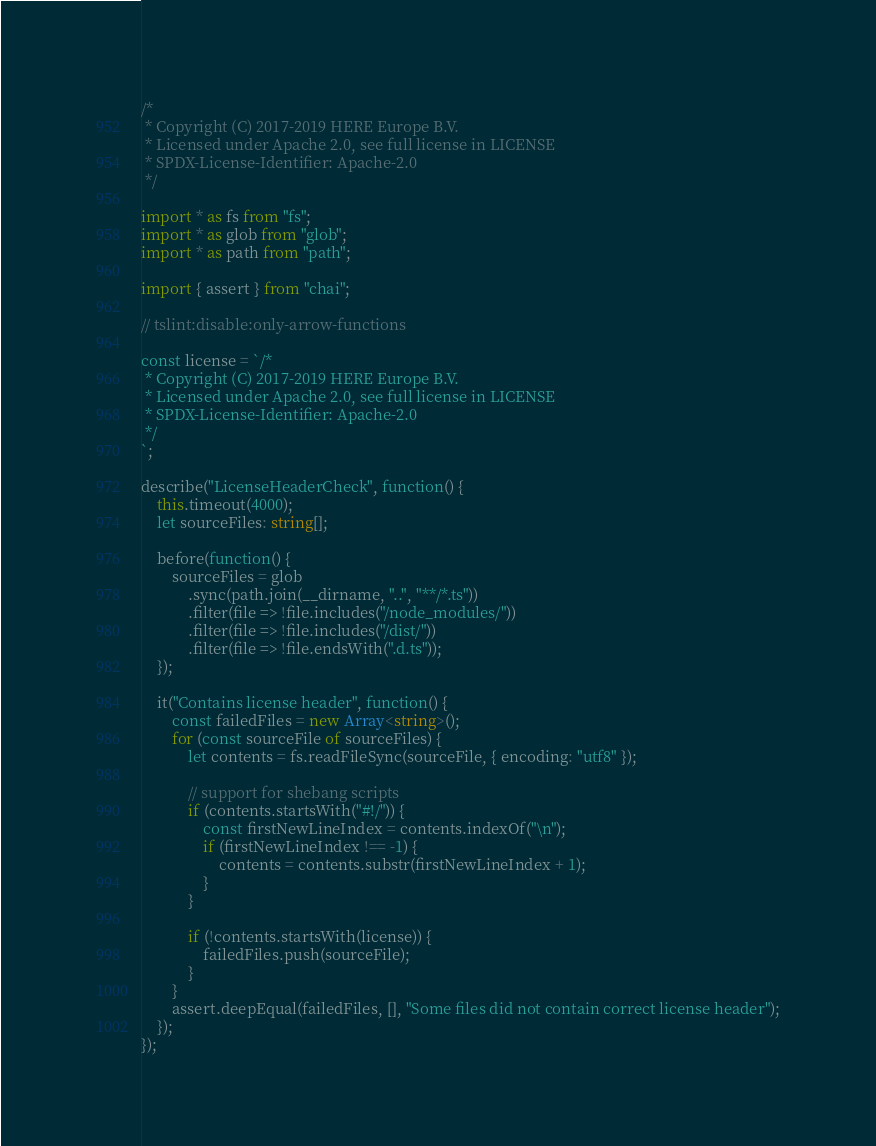<code> <loc_0><loc_0><loc_500><loc_500><_TypeScript_>/*
 * Copyright (C) 2017-2019 HERE Europe B.V.
 * Licensed under Apache 2.0, see full license in LICENSE
 * SPDX-License-Identifier: Apache-2.0
 */

import * as fs from "fs";
import * as glob from "glob";
import * as path from "path";

import { assert } from "chai";

// tslint:disable:only-arrow-functions

const license = `/*
 * Copyright (C) 2017-2019 HERE Europe B.V.
 * Licensed under Apache 2.0, see full license in LICENSE
 * SPDX-License-Identifier: Apache-2.0
 */
`;

describe("LicenseHeaderCheck", function() {
    this.timeout(4000);
    let sourceFiles: string[];

    before(function() {
        sourceFiles = glob
            .sync(path.join(__dirname, "..", "**/*.ts"))
            .filter(file => !file.includes("/node_modules/"))
            .filter(file => !file.includes("/dist/"))
            .filter(file => !file.endsWith(".d.ts"));
    });

    it("Contains license header", function() {
        const failedFiles = new Array<string>();
        for (const sourceFile of sourceFiles) {
            let contents = fs.readFileSync(sourceFile, { encoding: "utf8" });

            // support for shebang scripts
            if (contents.startsWith("#!/")) {
                const firstNewLineIndex = contents.indexOf("\n");
                if (firstNewLineIndex !== -1) {
                    contents = contents.substr(firstNewLineIndex + 1);
                }
            }

            if (!contents.startsWith(license)) {
                failedFiles.push(sourceFile);
            }
        }
        assert.deepEqual(failedFiles, [], "Some files did not contain correct license header");
    });
});
</code> 